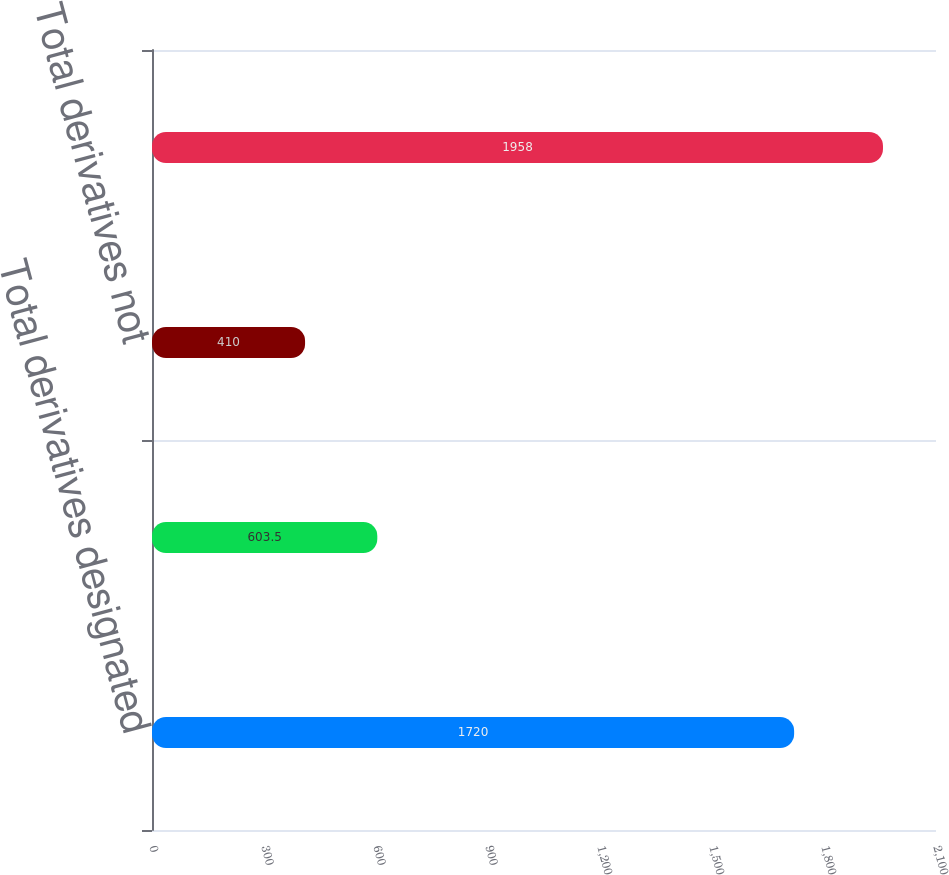Convert chart. <chart><loc_0><loc_0><loc_500><loc_500><bar_chart><fcel>Total derivatives designated<fcel>Total derivatives used for<fcel>Total derivatives not<fcel>Total Derivatives<nl><fcel>1720<fcel>603.5<fcel>410<fcel>1958<nl></chart> 